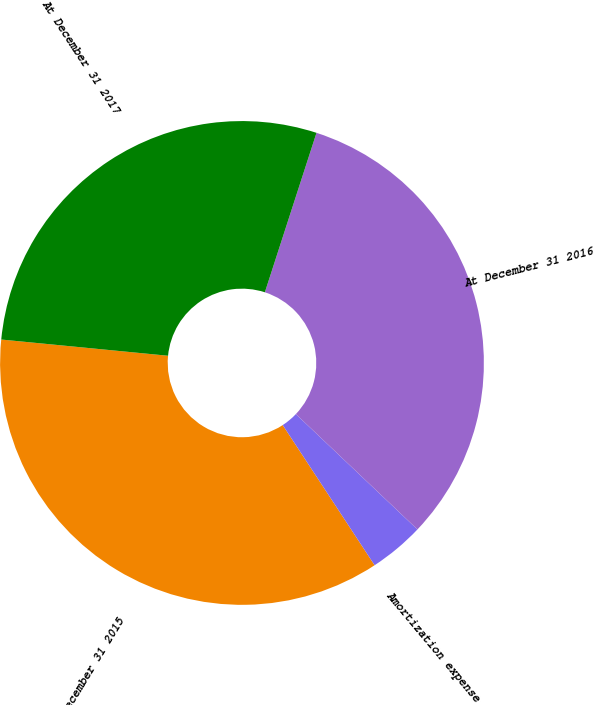Convert chart. <chart><loc_0><loc_0><loc_500><loc_500><pie_chart><fcel>At December 31 2015<fcel>Amortization expense<fcel>At December 31 2016<fcel>At December 31 2017<nl><fcel>35.78%<fcel>3.68%<fcel>32.1%<fcel>28.44%<nl></chart> 